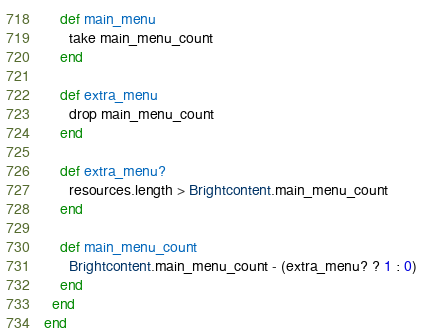Convert code to text. <code><loc_0><loc_0><loc_500><loc_500><_Ruby_>    def main_menu
      take main_menu_count
    end

    def extra_menu
      drop main_menu_count
    end

    def extra_menu?
      resources.length > Brightcontent.main_menu_count
    end

    def main_menu_count
      Brightcontent.main_menu_count - (extra_menu? ? 1 : 0)
    end
  end
end
</code> 